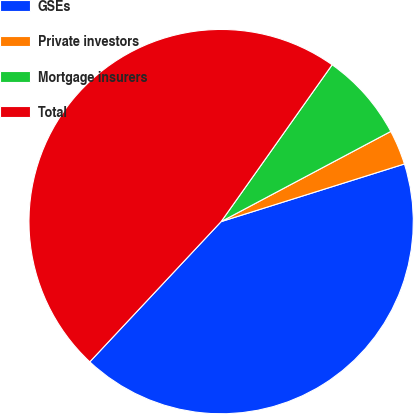<chart> <loc_0><loc_0><loc_500><loc_500><pie_chart><fcel>GSEs<fcel>Private investors<fcel>Mortgage insurers<fcel>Total<nl><fcel>41.83%<fcel>2.93%<fcel>7.42%<fcel>47.83%<nl></chart> 